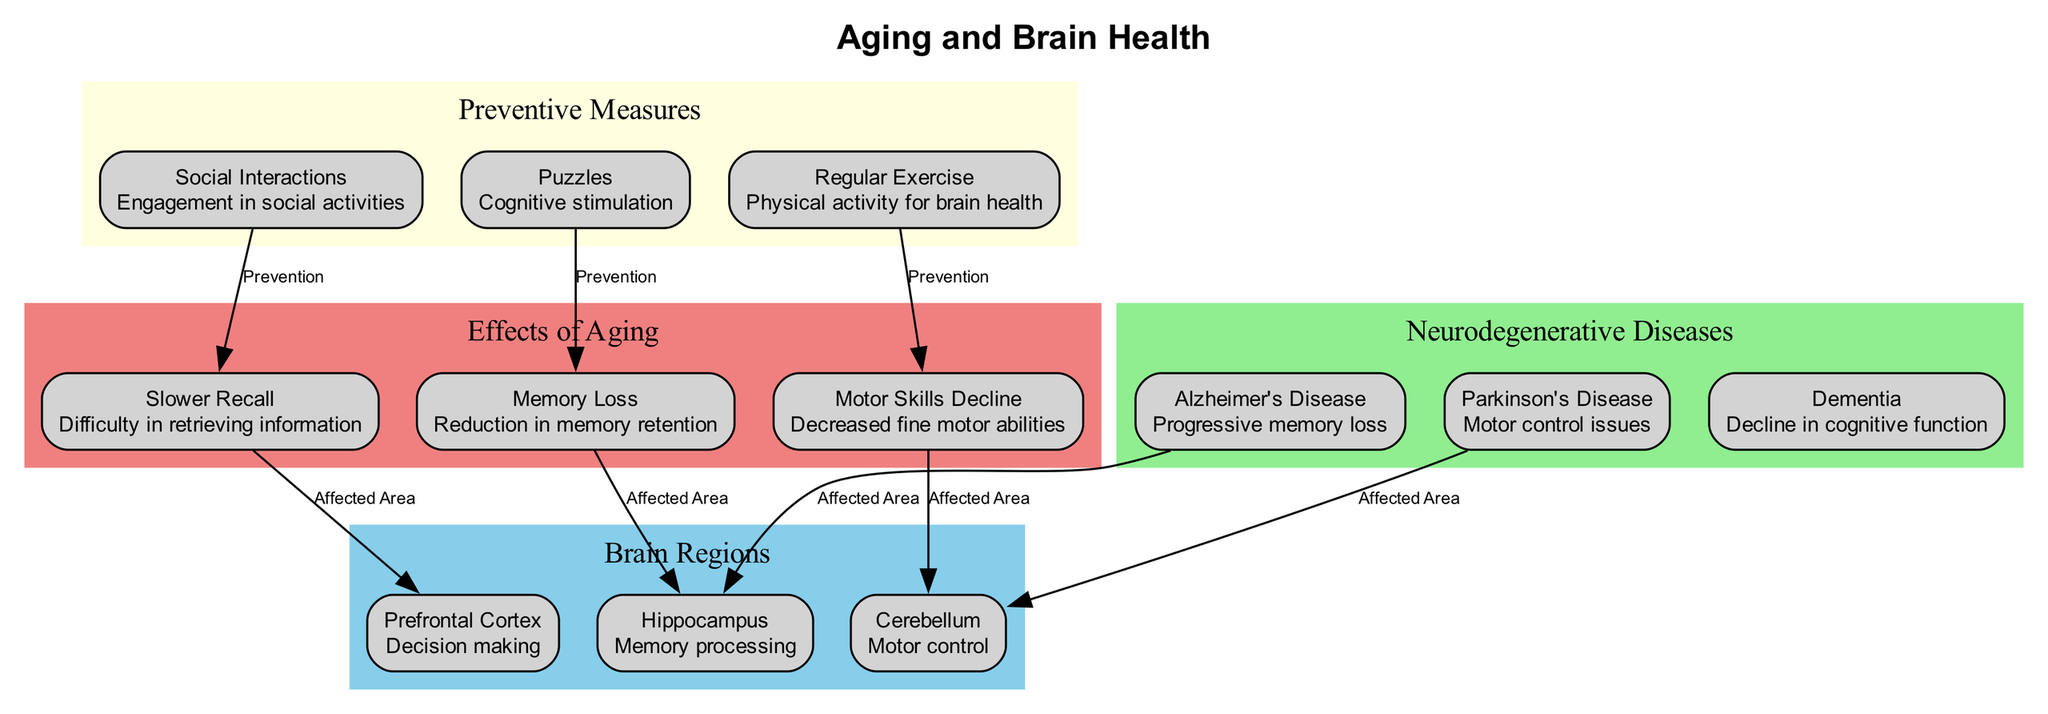What is the primary function of the hippocampus? The diagram indicates that the hippocampus is responsible for "Memory processing," as described in the section labeled "Brain Regions."
Answer: Memory processing Which disease is associated with progressive memory loss? The diagram identifies Alzheimer's Disease as the condition linked with "Progressive memory loss" under the "Neurodegenerative Diseases" section.
Answer: Alzheimer's Disease How many brain regions are listed in the diagram? In the "Brain Regions" section of the diagram, there are three brain regions identified: Hippocampus, Prefrontal Cortex, and Cerebellum. Thus, the total is three.
Answer: 3 What preventive measure is linked to cognitive stimulation? The diagram shows that "Puzzles" are connected to "Memory Loss" and labeled as a form of prevention, indicating the role of puzzles in cognitive stimulation.
Answer: Puzzles Which area is affected by slower recall? According to the diagram, "Slower Recall" impacts the "Prefrontal Cortex," as indicated in the connections section that specifies the affected areas.
Answer: Prefrontal Cortex What is the color used for the "Effects of Aging" section? The diagram shows the "Effects of Aging" section filled with the color light coral, which is indicated by the attribute assigned to that part of the diagram.
Answer: Light coral What relationship do regular exercise and motor skills decline have? The diagram illustrates that "Regular Exercise" is linked to "Motor Skills Decline" as a preventive measure, indicating the protective effect of exercise on motor skills.
Answer: Prevention Which brain region is most affected by Parkinson's disease? The diagram states that Parkinson's disease is associated with issues in motor control, specifically affecting the "Cerebellum," as labeled under the "Neurodegenerative Diseases" section.
Answer: Cerebellum 